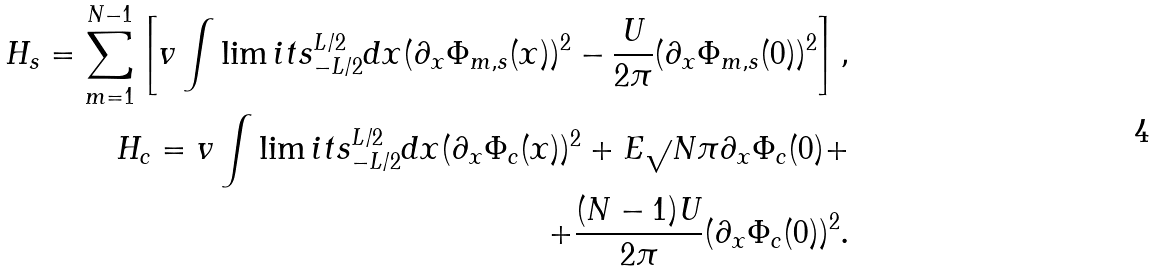<formula> <loc_0><loc_0><loc_500><loc_500>H _ { s } = \sum _ { m = 1 } ^ { N - 1 } \left [ v \int \lim i t s _ { - L / 2 } ^ { L / 2 } d x ( \partial _ { x } \Phi _ { m , s } ( x ) ) ^ { 2 } - \frac { U } { 2 \pi } ( \partial _ { x } \Phi _ { m , s } ( 0 ) ) ^ { 2 } \right ] , \\ H _ { c } = v \int \lim i t s _ { - L / 2 } ^ { L / 2 } d x ( \partial _ { x } \Phi _ { c } ( x ) ) ^ { 2 } + E \sqrt { } { N } \pi \partial _ { x } \Phi _ { c } ( 0 ) + \\ + \frac { ( N - 1 ) U } { 2 \pi } ( \partial _ { x } \Phi _ { c } ( 0 ) ) ^ { 2 } .</formula> 